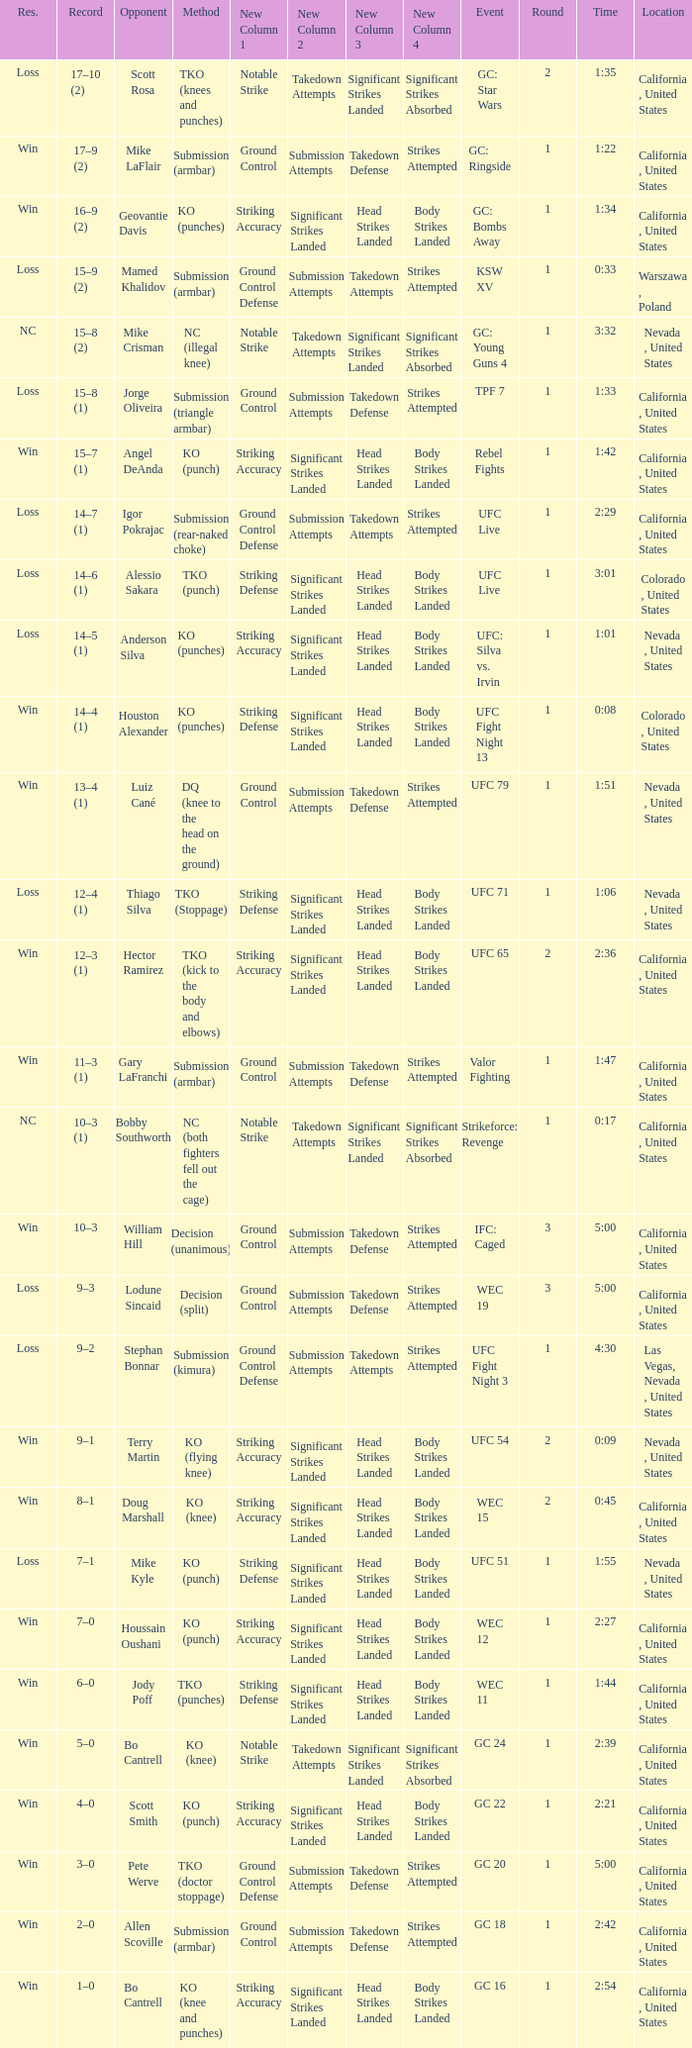What is the method where there is a loss with time 5:00? Decision (split). 